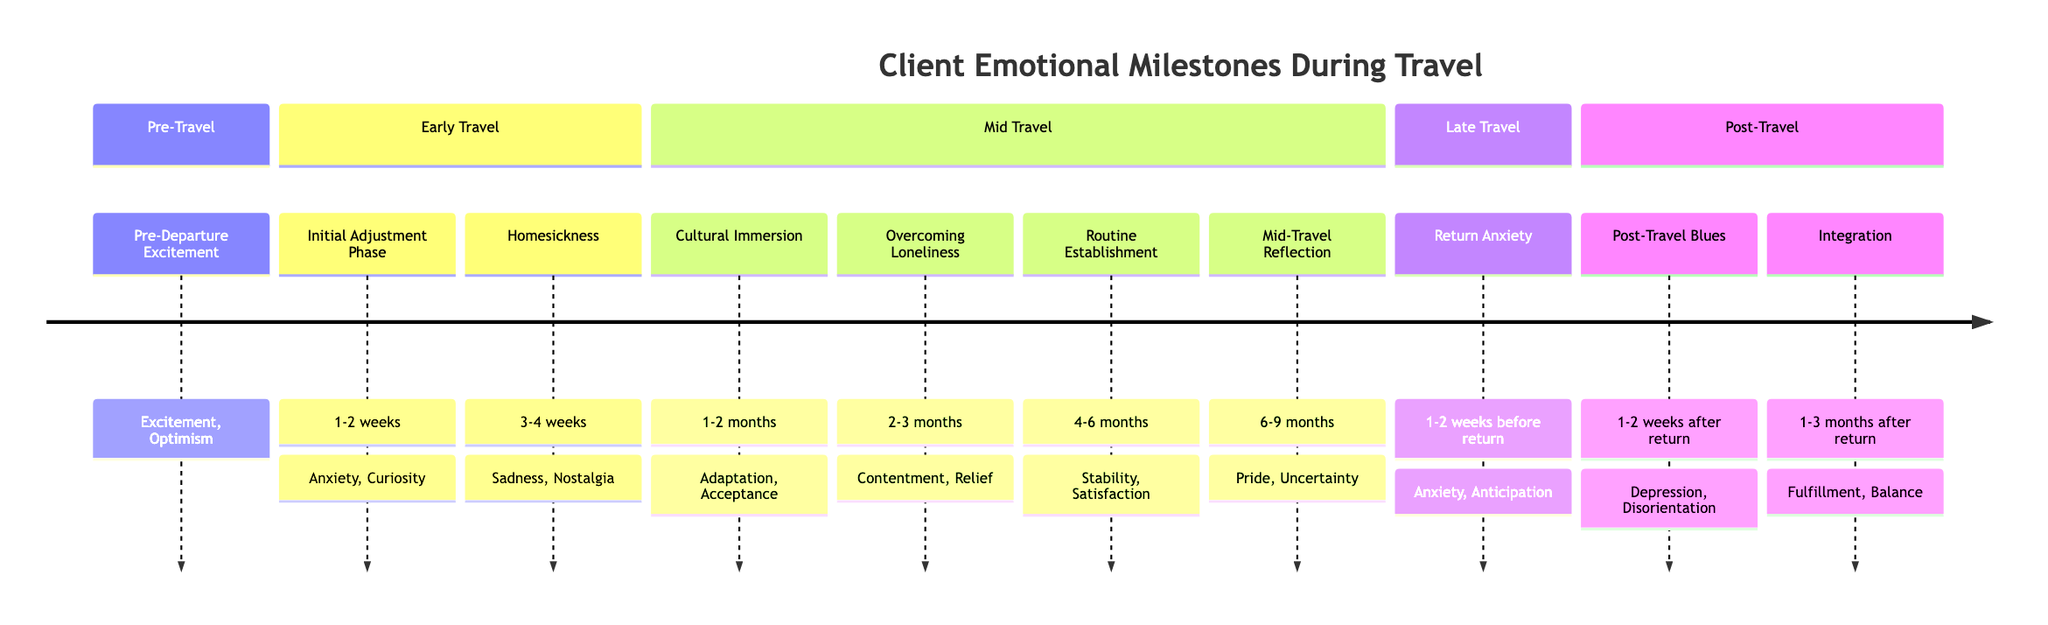What is the first milestone in the timeline? The first milestone listed in the timeline is "Pre-Departure Excitement," which is mentioned at the beginning of the diagram.
Answer: Pre-Departure Excitement How many emotional milestones are listed in the timeline? By counting each distinct milestone in the timeline, we identify a total of ten unique milestones.
Answer: 10 What emotions are associated with the "Homesickness" milestone? The diagram specifies that the emotions linked to the "Homesickness" milestone are "Sadness" and "Nostalgia."
Answer: Sadness, Nostalgia Which milestone occurs 1-2 weeks after departure? Looking through the diagram, the milestone that occurs 1-2 weeks after departure is "Initial Adjustment Phase."
Answer: Initial Adjustment Phase What is the emotional state during the "Mid-Travel Reflection"? The diagram indicates that the emotions during "Mid-Travel Reflection" are "Pride" and "Uncertainty."
Answer: Pride, Uncertainty How does the emotional state shift from "Return Anxiety" to "Post-Travel Blues"? The transition from "Return Anxiety" to "Post-Travel Blues" shows that as the trip nears its end, anxiety about returning leads to feelings of loss and disorientation after returning, indicating a shift from anticipation to depression.
Answer: Anxiety to Depression Which milestone comes 1-3 months after return? The milestone that is noted to occur 1-3 months after return is "Integration," as mentioned towards the end of the timeline.
Answer: Integration What is the emotional response to "Cultural Immersion"? The diagram identifies "Adaptation" and "Acceptance" as the emotional responses associated with the "Cultural Immersion" milestone.
Answer: Adaptation, Acceptance At what point does the client begin to build new connections? The timeline indicates that the client starts building new friendships and connections during the "Overcoming Loneliness" milestone, which occurs 2-3 months after departure.
Answer: Overcoming Loneliness 